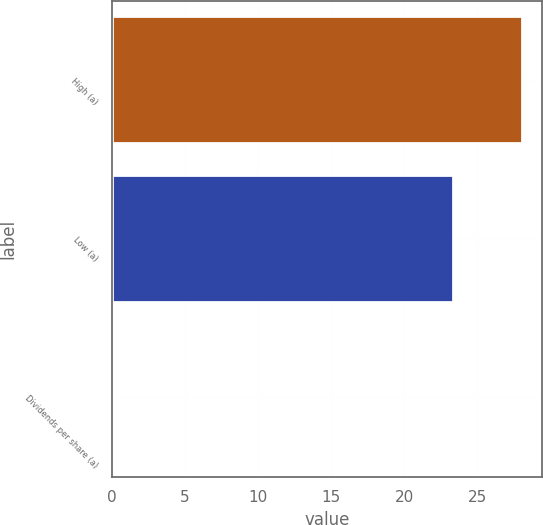Convert chart to OTSL. <chart><loc_0><loc_0><loc_500><loc_500><bar_chart><fcel>High (a)<fcel>Low (a)<fcel>Dividends per share (a)<nl><fcel>28.05<fcel>23.35<fcel>0.05<nl></chart> 